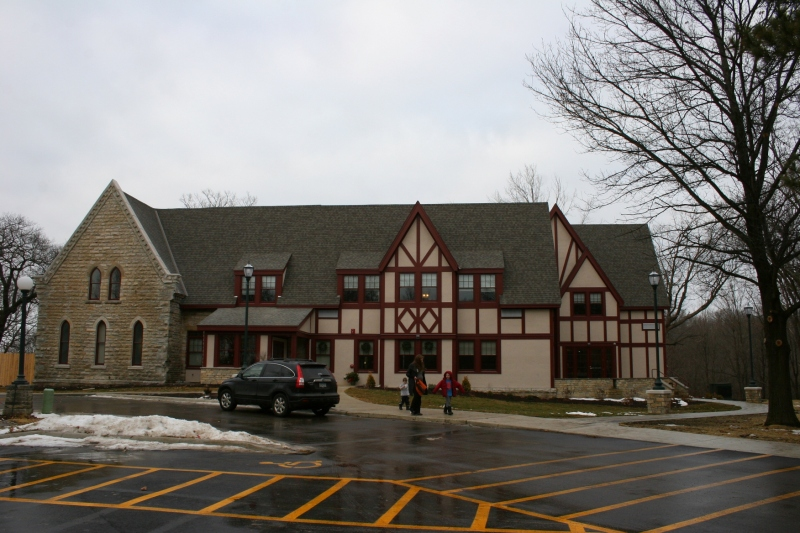What events or activities might typically take place in this building today? Given its structure and design, which includes large windows and spacious design, the building likely hosts a variety of community-focused events. These could include educational workshops, local art and cultural exhibitions, and perhaps community meetings or social gatherings. The layout and accessibility suggest it is well-suited to cater to both formal and informal events, encouraging a vibrant local culture. 